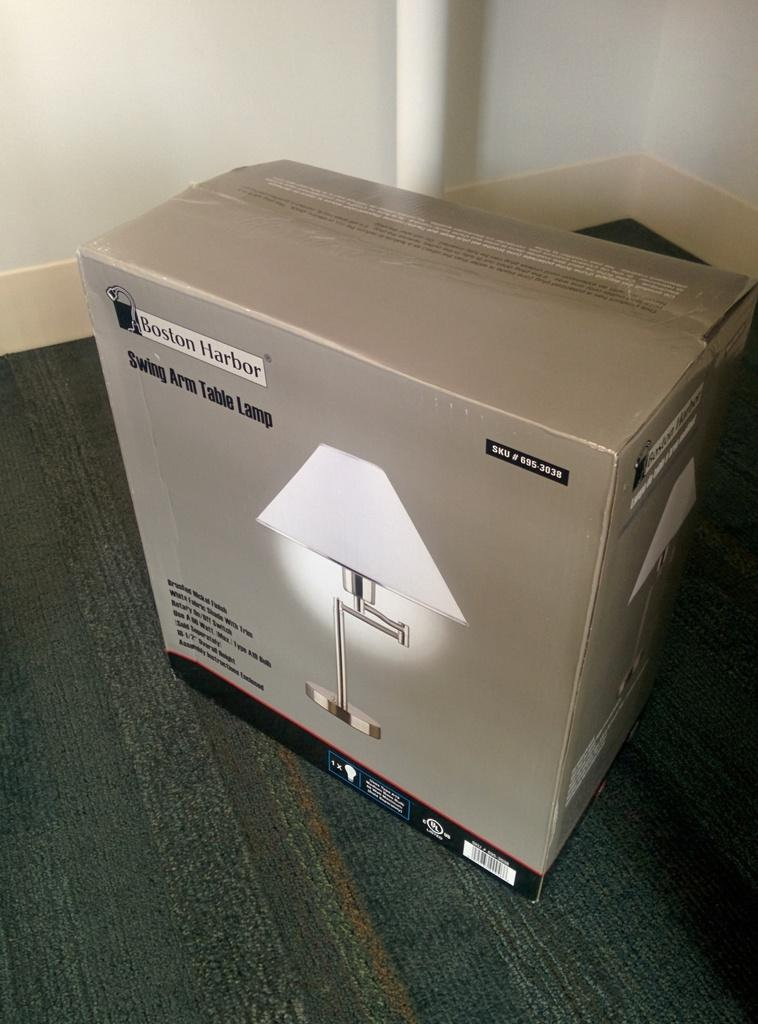What is the main object in the center of the image? There is a cardboard box in the center of the image. Where is the cardboard box located? The cardboard box is on the floor. What can be seen in the background of the image? There is a pipe and a wall in the background of the image. What type of agreement is being discussed in the image? There is no discussion or agreement present in the image; it features a cardboard box on the floor with a pipe and a wall in the background. 